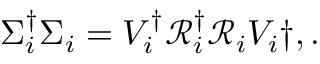Convert formula to latex. <formula><loc_0><loc_0><loc_500><loc_500>\begin{array} { r } { \Sigma _ { i } ^ { \dagger } \Sigma _ { i } = V _ { i } ^ { \dagger } \mathcal { R } _ { i } ^ { \dagger } \mathcal { R } _ { i } V _ { i } \dag , . } \end{array}</formula> 